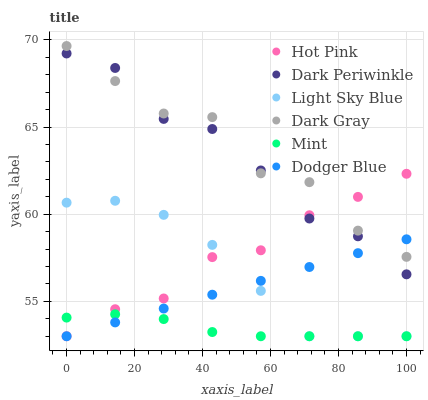Does Mint have the minimum area under the curve?
Answer yes or no. Yes. Does Dark Gray have the maximum area under the curve?
Answer yes or no. Yes. Does Light Sky Blue have the minimum area under the curve?
Answer yes or no. No. Does Light Sky Blue have the maximum area under the curve?
Answer yes or no. No. Is Dodger Blue the smoothest?
Answer yes or no. Yes. Is Dark Gray the roughest?
Answer yes or no. Yes. Is Light Sky Blue the smoothest?
Answer yes or no. No. Is Light Sky Blue the roughest?
Answer yes or no. No. Does Hot Pink have the lowest value?
Answer yes or no. Yes. Does Dark Gray have the lowest value?
Answer yes or no. No. Does Dark Gray have the highest value?
Answer yes or no. Yes. Does Light Sky Blue have the highest value?
Answer yes or no. No. Is Light Sky Blue less than Dark Gray?
Answer yes or no. Yes. Is Dark Periwinkle greater than Light Sky Blue?
Answer yes or no. Yes. Does Light Sky Blue intersect Dodger Blue?
Answer yes or no. Yes. Is Light Sky Blue less than Dodger Blue?
Answer yes or no. No. Is Light Sky Blue greater than Dodger Blue?
Answer yes or no. No. Does Light Sky Blue intersect Dark Gray?
Answer yes or no. No. 